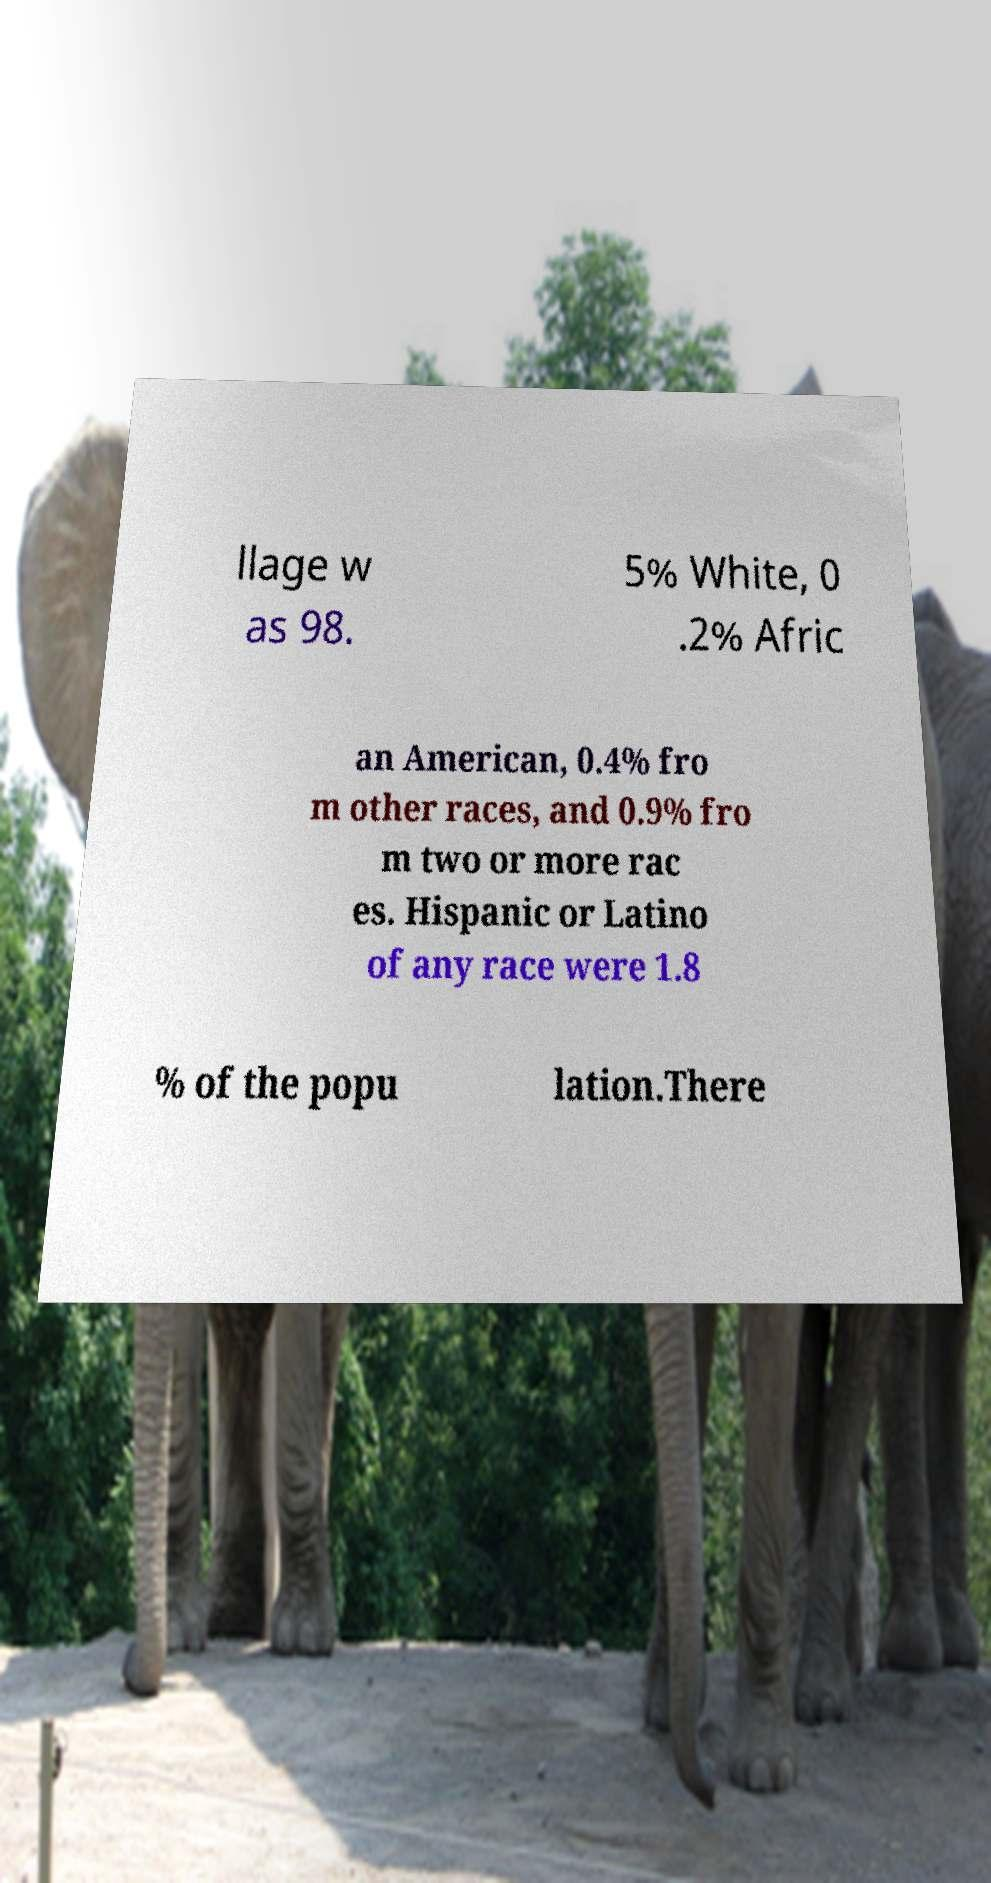What messages or text are displayed in this image? I need them in a readable, typed format. llage w as 98. 5% White, 0 .2% Afric an American, 0.4% fro m other races, and 0.9% fro m two or more rac es. Hispanic or Latino of any race were 1.8 % of the popu lation.There 